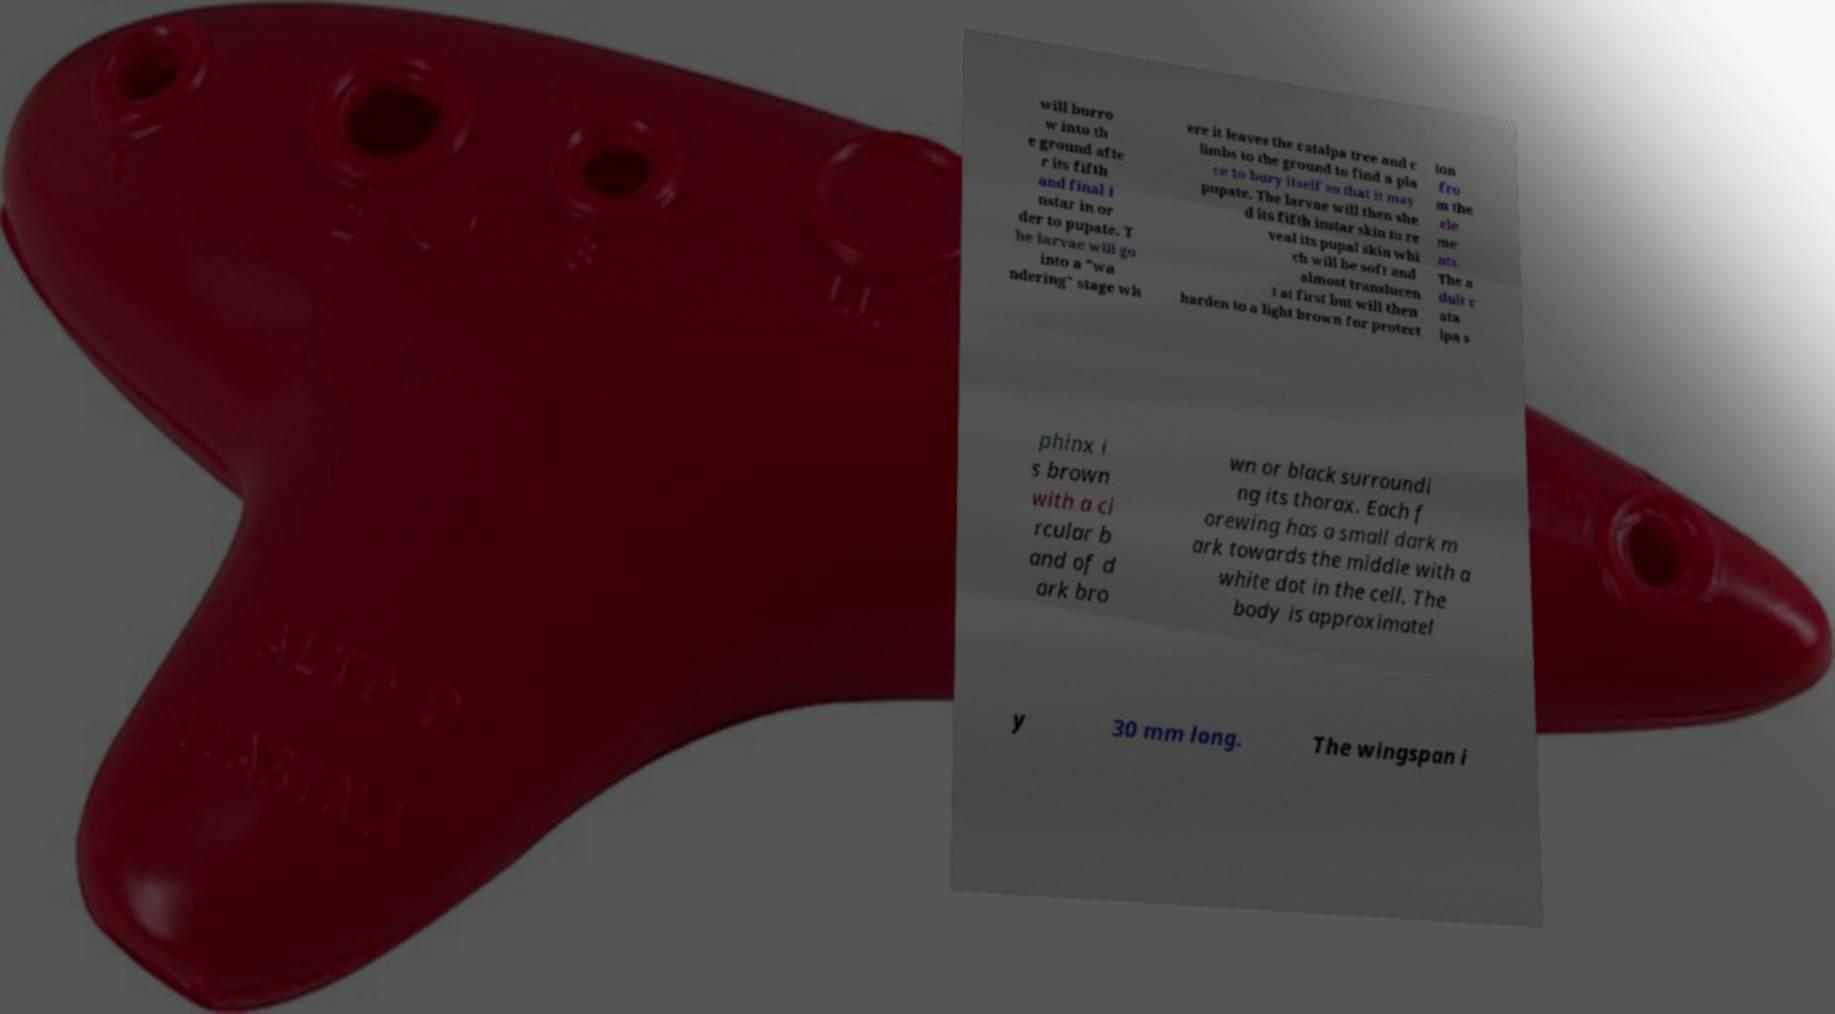Could you assist in decoding the text presented in this image and type it out clearly? will burro w into th e ground afte r its fifth and final i nstar in or der to pupate. T he larvae will go into a "wa ndering" stage wh ere it leaves the catalpa tree and c limbs to the ground to find a pla ce to bury itself so that it may pupate. The larvae will then she d its fifth instar skin to re veal its pupal skin whi ch will be soft and almost translucen t at first but will then harden to a light brown for protect ion fro m the ele me nts. The a dult c ata lpa s phinx i s brown with a ci rcular b and of d ark bro wn or black surroundi ng its thorax. Each f orewing has a small dark m ark towards the middle with a white dot in the cell. The body is approximatel y 30 mm long. The wingspan i 